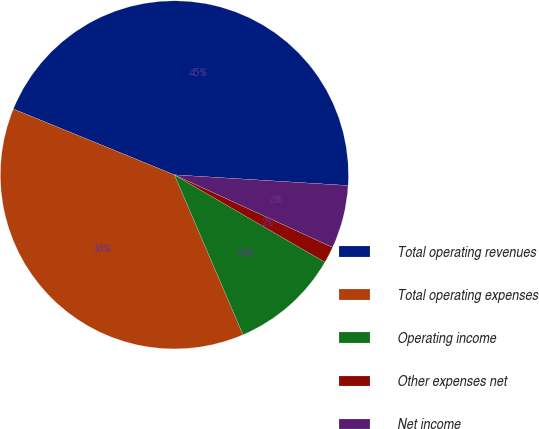<chart> <loc_0><loc_0><loc_500><loc_500><pie_chart><fcel>Total operating revenues<fcel>Total operating expenses<fcel>Operating income<fcel>Other expenses net<fcel>Net income<nl><fcel>44.8%<fcel>37.63%<fcel>10.18%<fcel>1.53%<fcel>5.86%<nl></chart> 